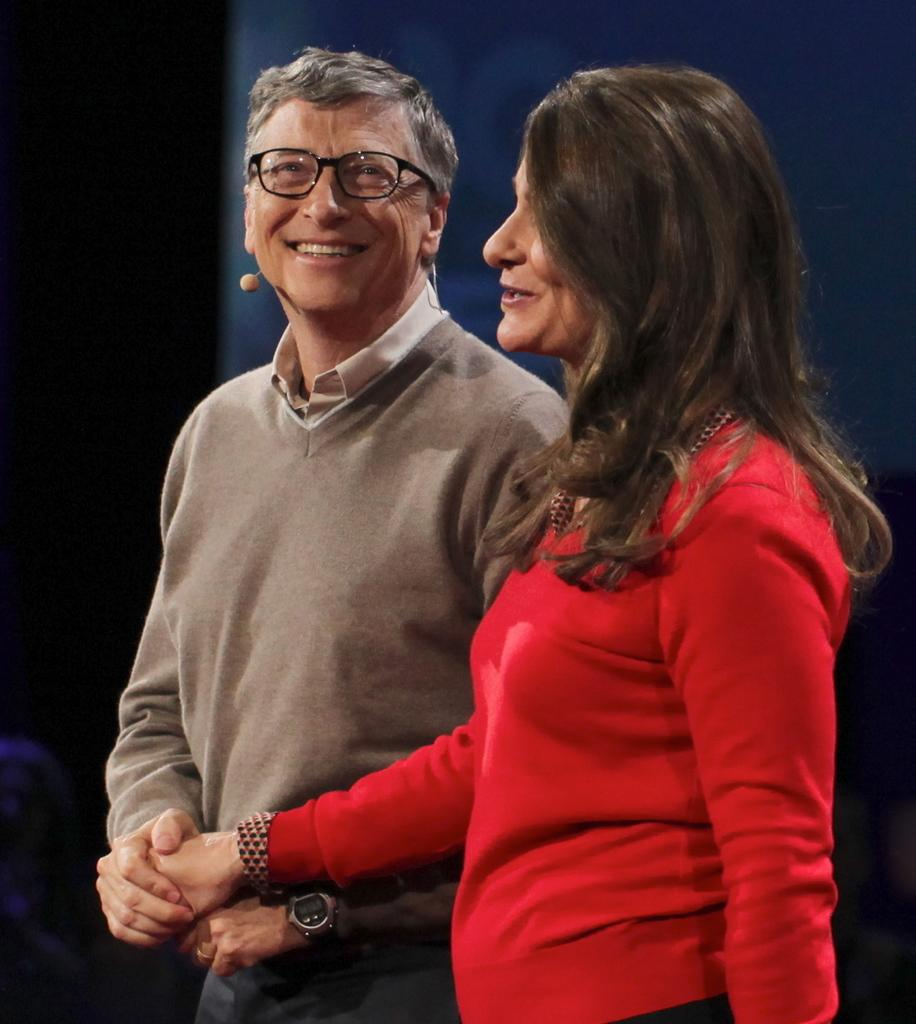How many individuals are present in the image? There are two people in the image. What are the people doing in the image? The people are standing. Can you describe the background of the image? The background of the image is dark. What type of floor can be seen in the image? There is no floor visible in the image; it only shows two people standing against a dark background. 